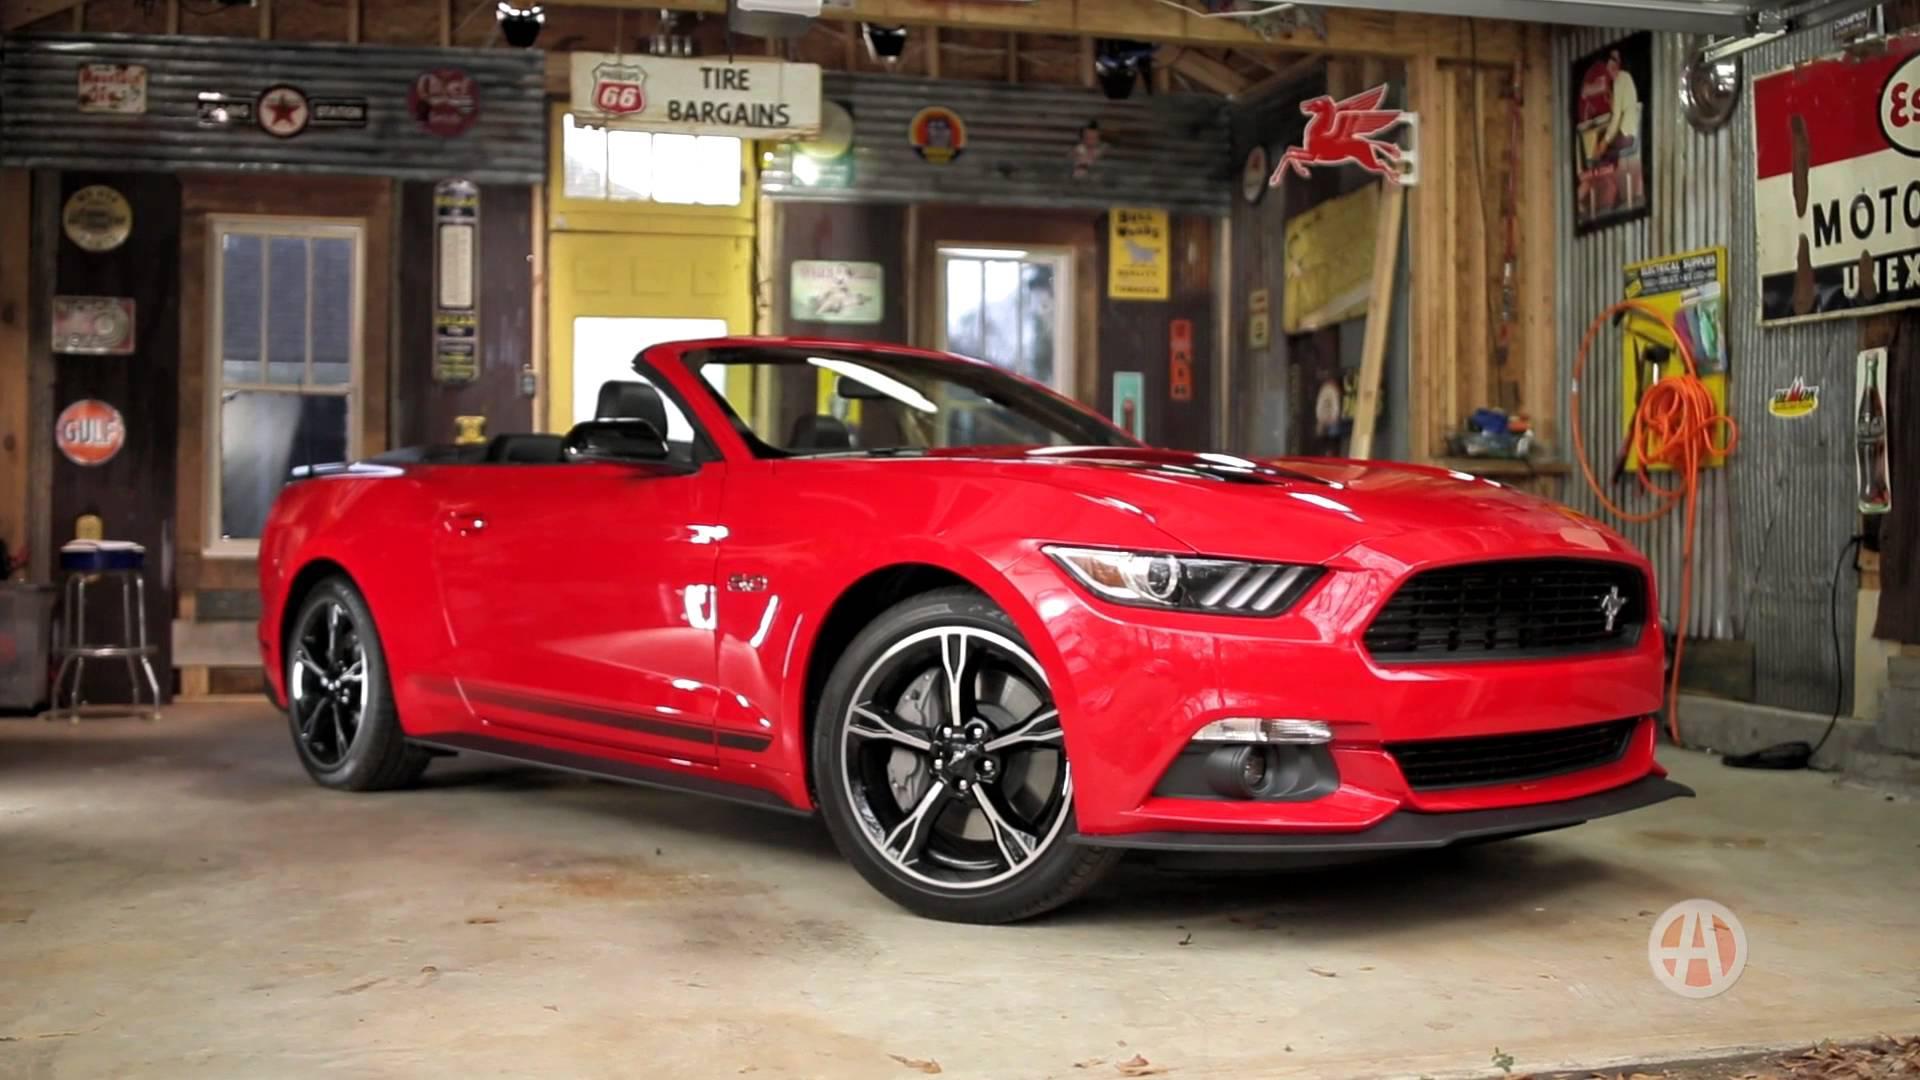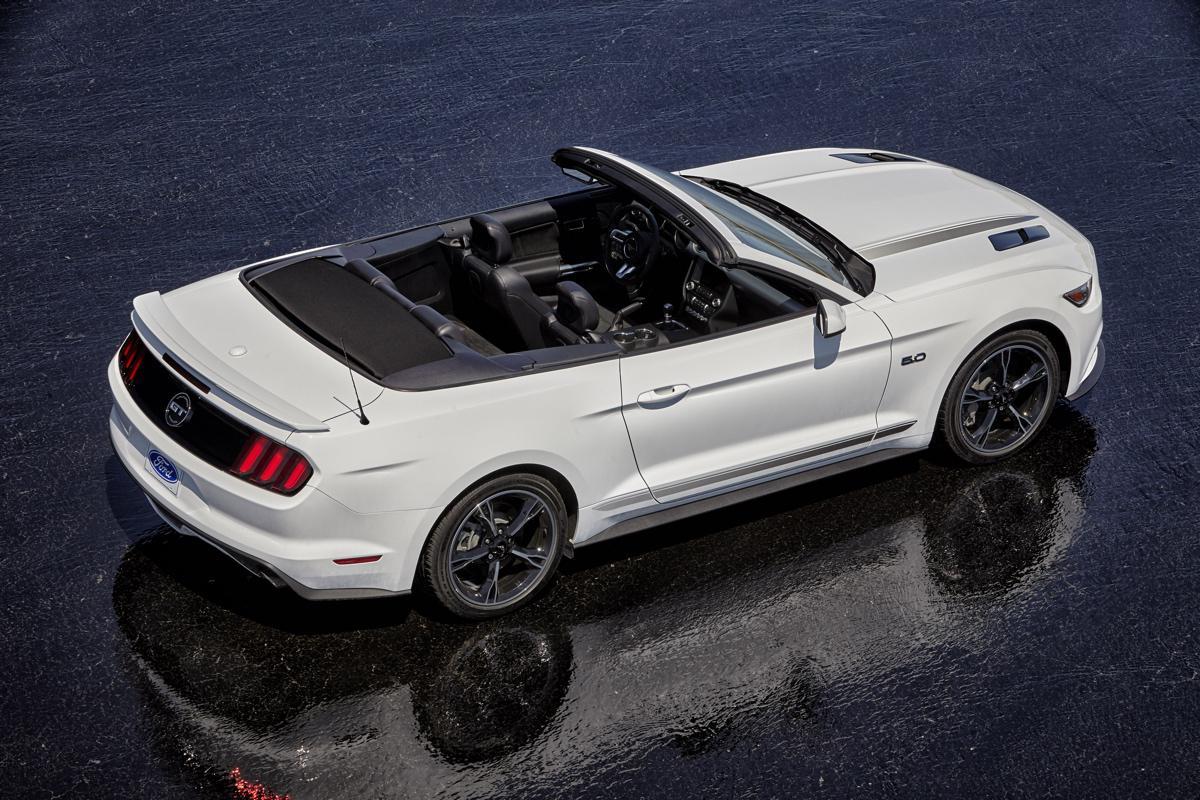The first image is the image on the left, the second image is the image on the right. Examine the images to the left and right. Is the description "a convertible mustang is parked on a sandy beach" accurate? Answer yes or no. No. The first image is the image on the left, the second image is the image on the right. Assess this claim about the two images: "One Ford Mustang is parked in dirt.". Correct or not? Answer yes or no. No. 